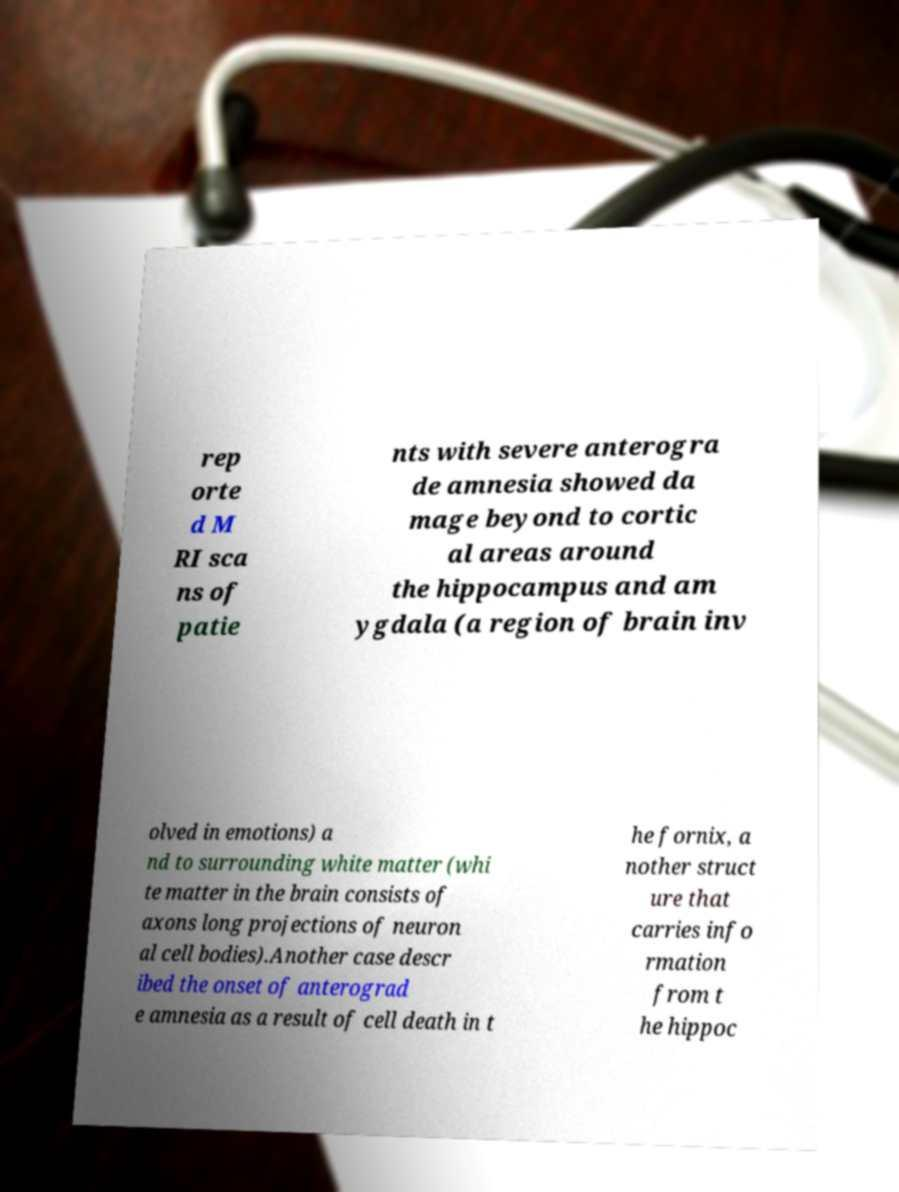Can you read and provide the text displayed in the image?This photo seems to have some interesting text. Can you extract and type it out for me? rep orte d M RI sca ns of patie nts with severe anterogra de amnesia showed da mage beyond to cortic al areas around the hippocampus and am ygdala (a region of brain inv olved in emotions) a nd to surrounding white matter (whi te matter in the brain consists of axons long projections of neuron al cell bodies).Another case descr ibed the onset of anterograd e amnesia as a result of cell death in t he fornix, a nother struct ure that carries info rmation from t he hippoc 